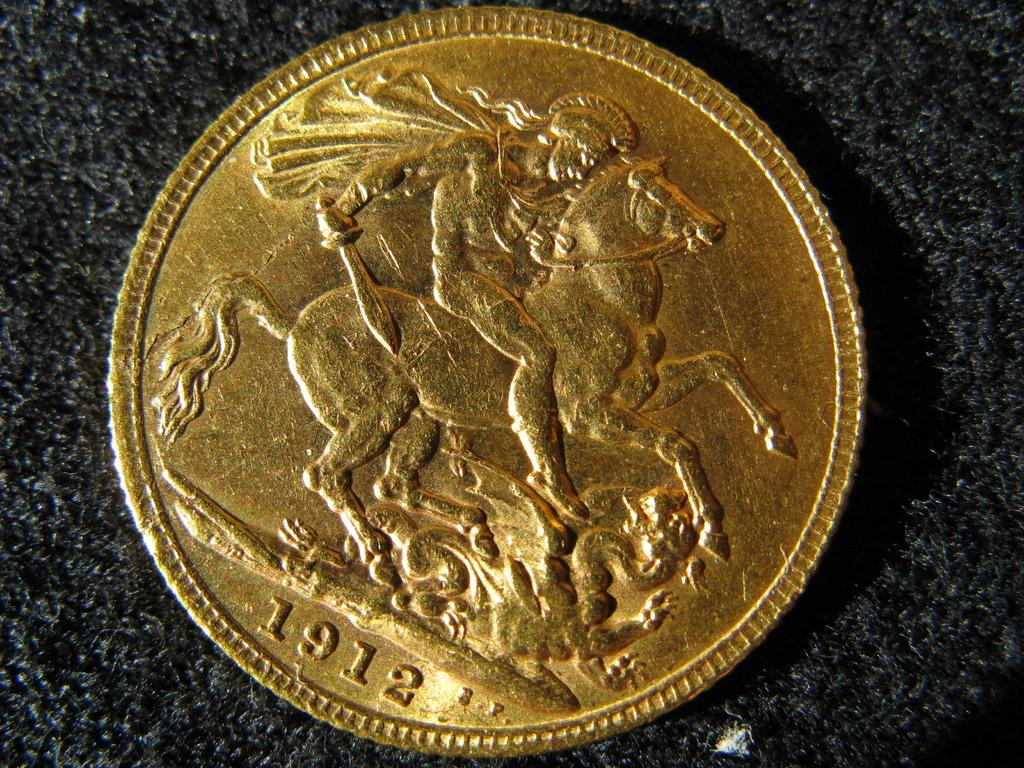What object is the main focus of the image? The main focus of the image is a coin. What is depicted on the surface of the coin? The coin has an image on its surface. Are there any numbers on the coin? Yes, the coin has numbers on it. What type of fang can be seen in the image? There is no fang present in the image; it features a coin with an image and numbers. How many pets are visible in the image? There are no pets visible in the image; it features a coin with an image and numbers. 